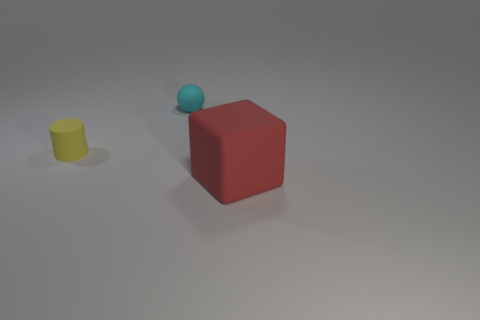Add 2 tiny cylinders. How many objects exist? 5 Subtract all blocks. How many objects are left? 2 Subtract 1 cylinders. How many cylinders are left? 0 Subtract all blue cylinders. How many brown spheres are left? 0 Add 3 tiny blue metallic objects. How many tiny blue metallic objects exist? 3 Subtract 1 cyan spheres. How many objects are left? 2 Subtract all tiny matte balls. Subtract all spheres. How many objects are left? 1 Add 1 matte cylinders. How many matte cylinders are left? 2 